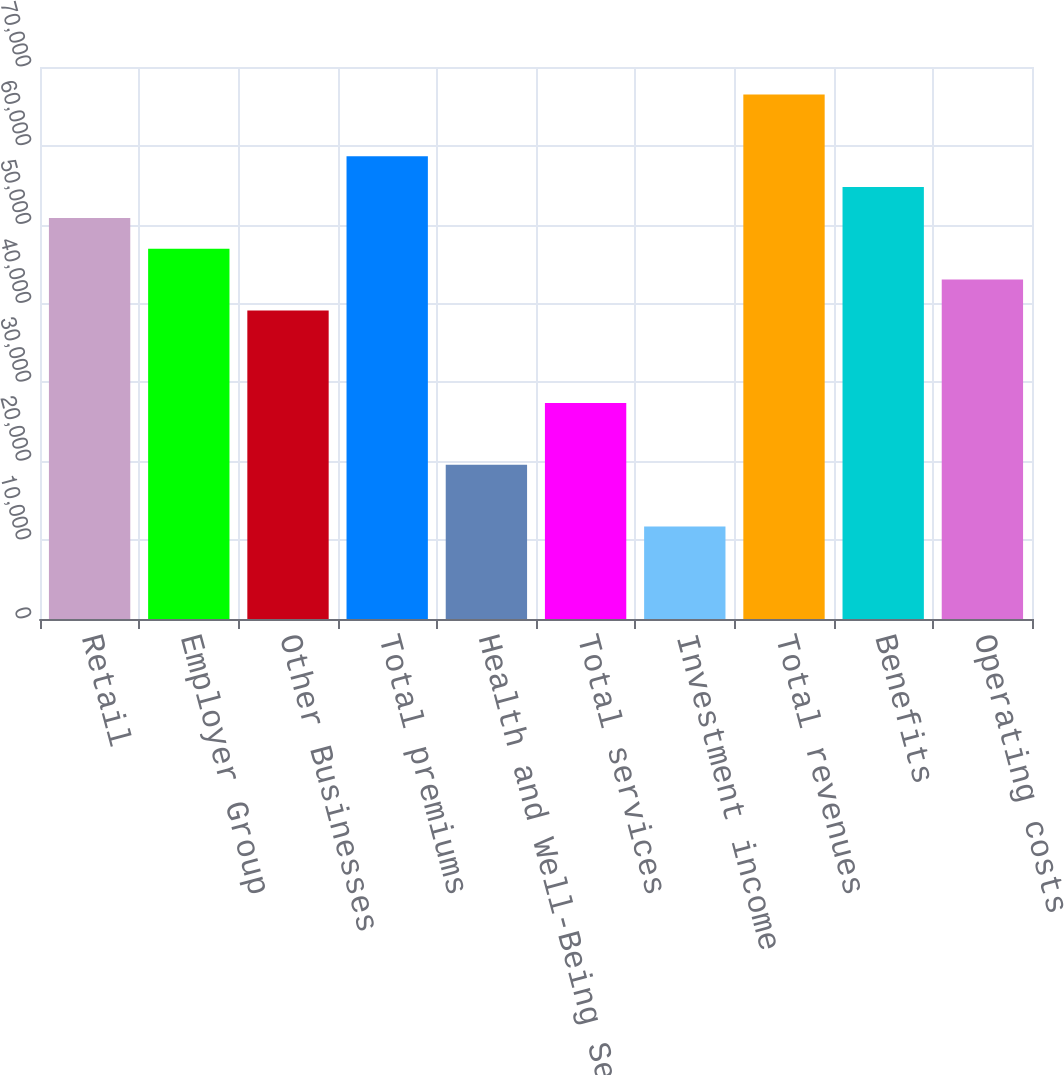Convert chart. <chart><loc_0><loc_0><loc_500><loc_500><bar_chart><fcel>Retail<fcel>Employer Group<fcel>Other Businesses<fcel>Total premiums<fcel>Health and Well-Being Services<fcel>Total services<fcel>Investment income<fcel>Total revenues<fcel>Benefits<fcel>Operating costs<nl><fcel>50861.5<fcel>46949.7<fcel>39126<fcel>58685.2<fcel>19566.7<fcel>27390.4<fcel>11743<fcel>66508.9<fcel>54773.4<fcel>43037.8<nl></chart> 